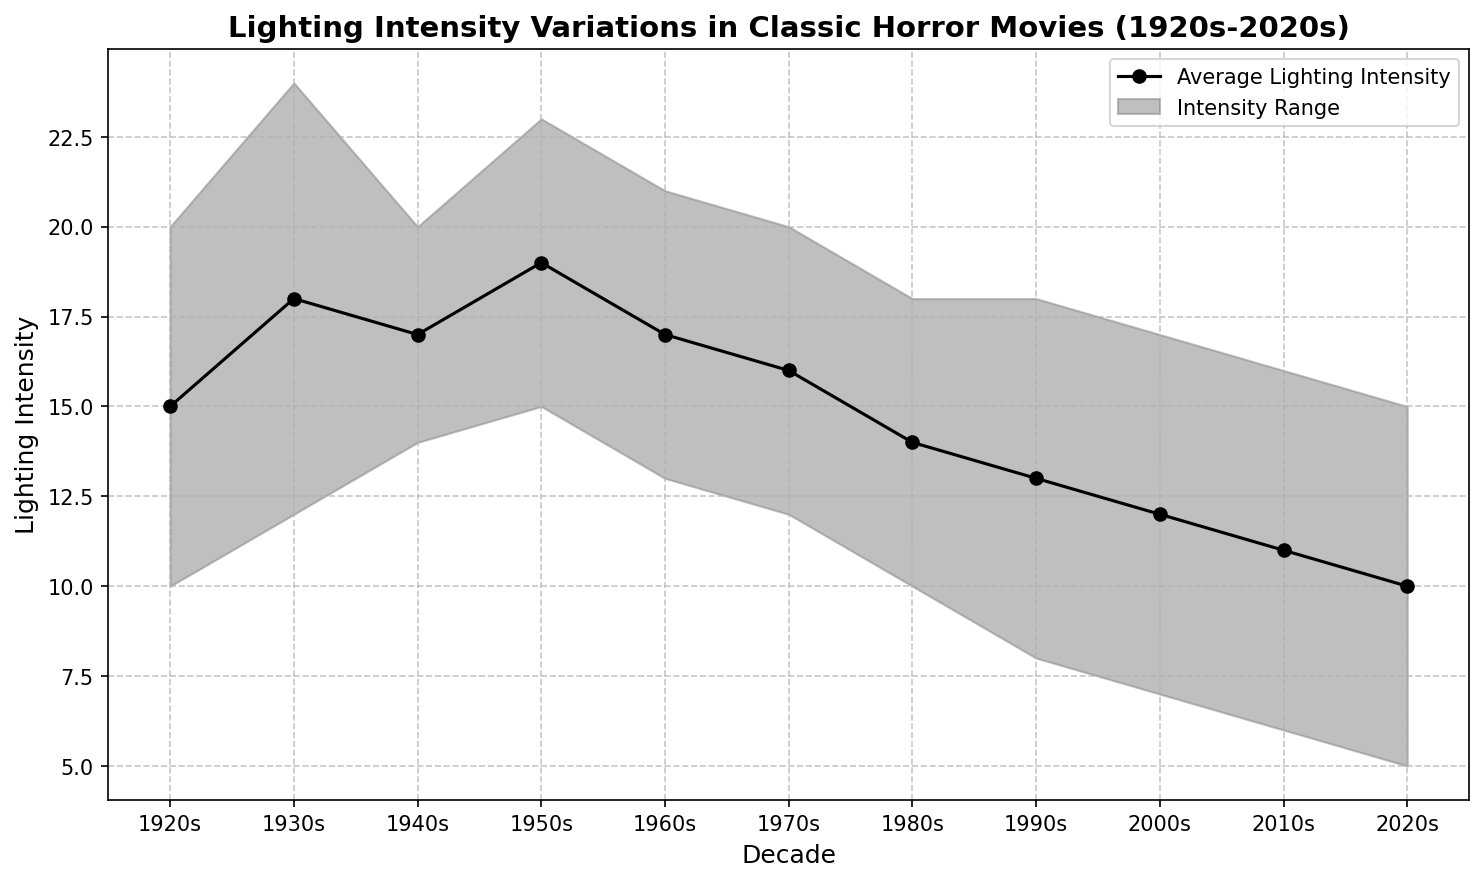what is the lighting intensity range showcased in the 1950s? To find the lighting intensity range, subtract the lower bound from the upper bound for the 1950s. Lower bound = 15, Upper bound = 23. Range = 23 - 15 = 8.
Answer: 8 How has the average lighting intensity changed from the 1920s to the 2020s? The plot shows the average lighting intensity for each decade. In the 1920s, it is 15, and in the 2020s, it is 10. Subtract the 2020s value from the 1920s value to find the change: 15 - 10 = 5.
Answer: Decreased by 5 In which decade is the difference between the average lighting intensity and the upper bound the least? Look at the gap between the average intensity line and the upper bound line for each decade. The least difference occurs in the 1980s, where the average is 14 and the upper bound is 18. The difference is 4 in the 1980s.
Answer: 1980s Is there any decade where the lower lighting intensity bound remained the same as in the previous decade? Check the lower bounds for each pair of consecutive decades to see if any values repeat. The lower bound remained the same between the 1970s and 1980s, both at 10.
Answer: No Which decade had the highest variability in lighting intensity? Variability can be estimated by the range (upper bound - lower bound). Calculate this for each decade; 1930s has the highest variability: 24 - 12 = 12.
Answer: 1930s By how much did the lower lighting intensity bound decrease from the 1970s to the 2020s? Find the lower bounds for these decades: 1970s is 12, 2020s is 5. Subtract the 2020s value from the 1970s value: 12 - 5 = 7.
Answer: 7 Which decade has the most significant drop in average lighting intensity compared to the previous decade? Identify the decade-to-decade changes in average intensity. The most significant drop is from the 1930s (18) to the 1940s (17). The most significant drop is from the 1950s (19) to the 1960s (17), a decrease of 2.
Answer: 1950s to 1960s What is the trend in upper lighting intensity bound from the 2000s to the 2020s? Find the upper bounds for these decades: 2000s is 17, 2010s is 16, 2020s is 15. The trend shows a decrease.
Answer: Decreasing Which decade has a consistent average lighting intensity? Locate the decade where the average line appears flat. From the visual, the 1960s and 1970s both have 17, indicating consistency.
Answer: 1960s Compare the lighting intensity ranges of the 1940s and 2010s and determine which is larger. Calculate the range for each: 1940s (20 - 14 = 6), 2010s (16 - 6 = 10). Compare the ranges: the 2010s range is larger.
Answer: 2010s have a larger range 